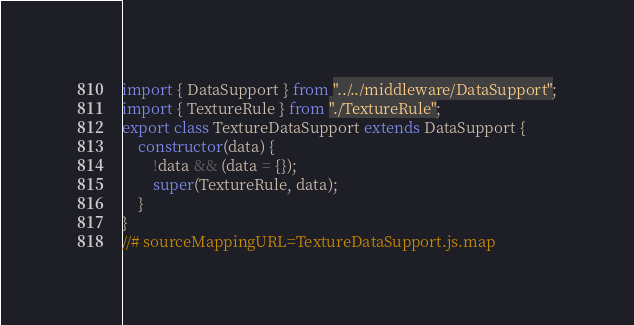<code> <loc_0><loc_0><loc_500><loc_500><_JavaScript_>import { DataSupport } from "../../middleware/DataSupport";
import { TextureRule } from "./TextureRule";
export class TextureDataSupport extends DataSupport {
    constructor(data) {
        !data && (data = {});
        super(TextureRule, data);
    }
}
//# sourceMappingURL=TextureDataSupport.js.map</code> 